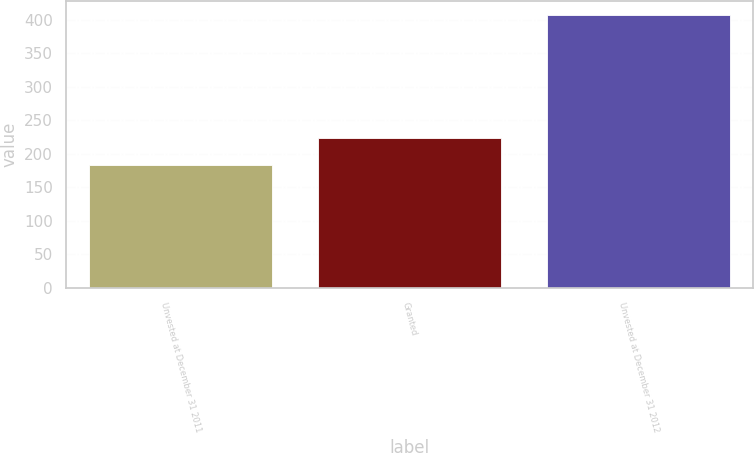Convert chart. <chart><loc_0><loc_0><loc_500><loc_500><bar_chart><fcel>Unvested at December 31 2011<fcel>Granted<fcel>Unvested at December 31 2012<nl><fcel>184<fcel>224<fcel>408<nl></chart> 